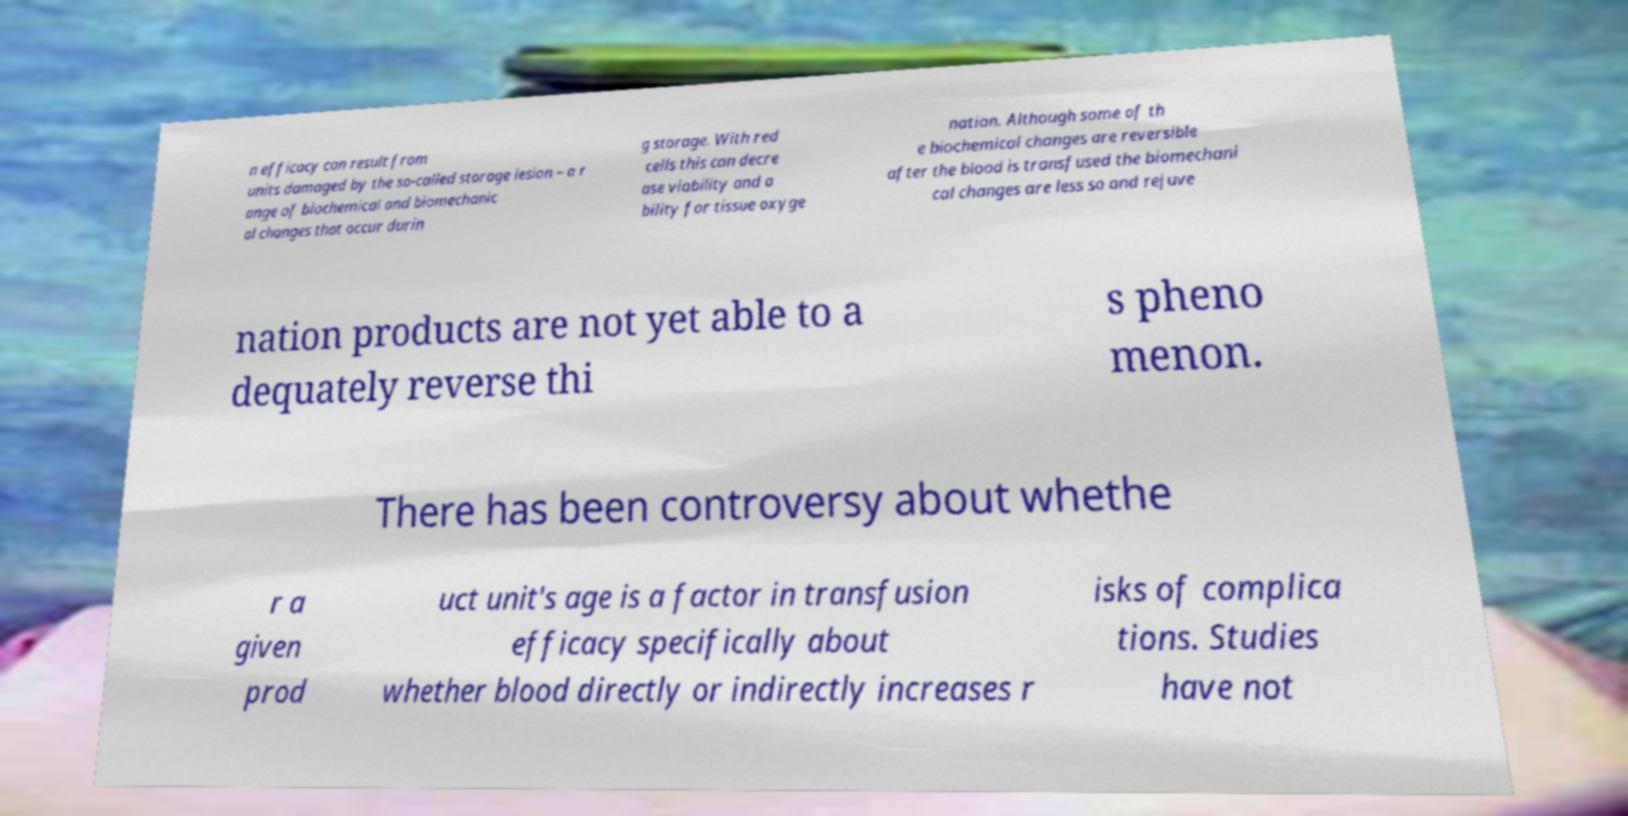Please identify and transcribe the text found in this image. n efficacy can result from units damaged by the so-called storage lesion – a r ange of biochemical and biomechanic al changes that occur durin g storage. With red cells this can decre ase viability and a bility for tissue oxyge nation. Although some of th e biochemical changes are reversible after the blood is transfused the biomechani cal changes are less so and rejuve nation products are not yet able to a dequately reverse thi s pheno menon. There has been controversy about whethe r a given prod uct unit's age is a factor in transfusion efficacy specifically about whether blood directly or indirectly increases r isks of complica tions. Studies have not 